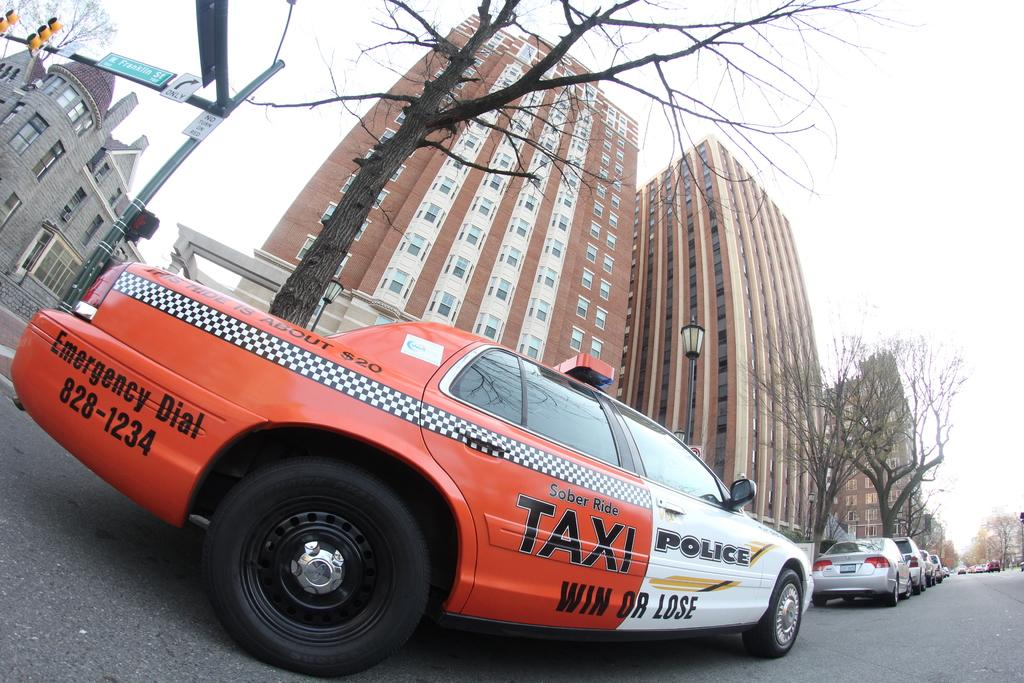<image>
Share a concise interpretation of the image provided. an orange and white car has both a taxi logo and a police logo on it. 